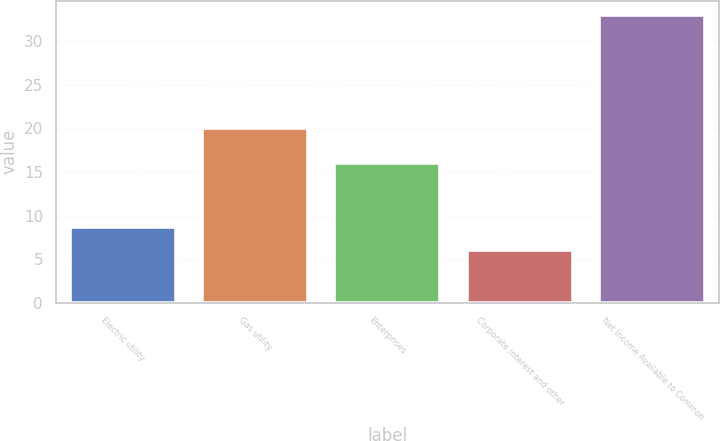Convert chart to OTSL. <chart><loc_0><loc_0><loc_500><loc_500><bar_chart><fcel>Electric utility<fcel>Gas utility<fcel>Enterprises<fcel>Corporate interest and other<fcel>Net Income Available to Common<nl><fcel>8.7<fcel>20<fcel>16<fcel>6<fcel>33<nl></chart> 